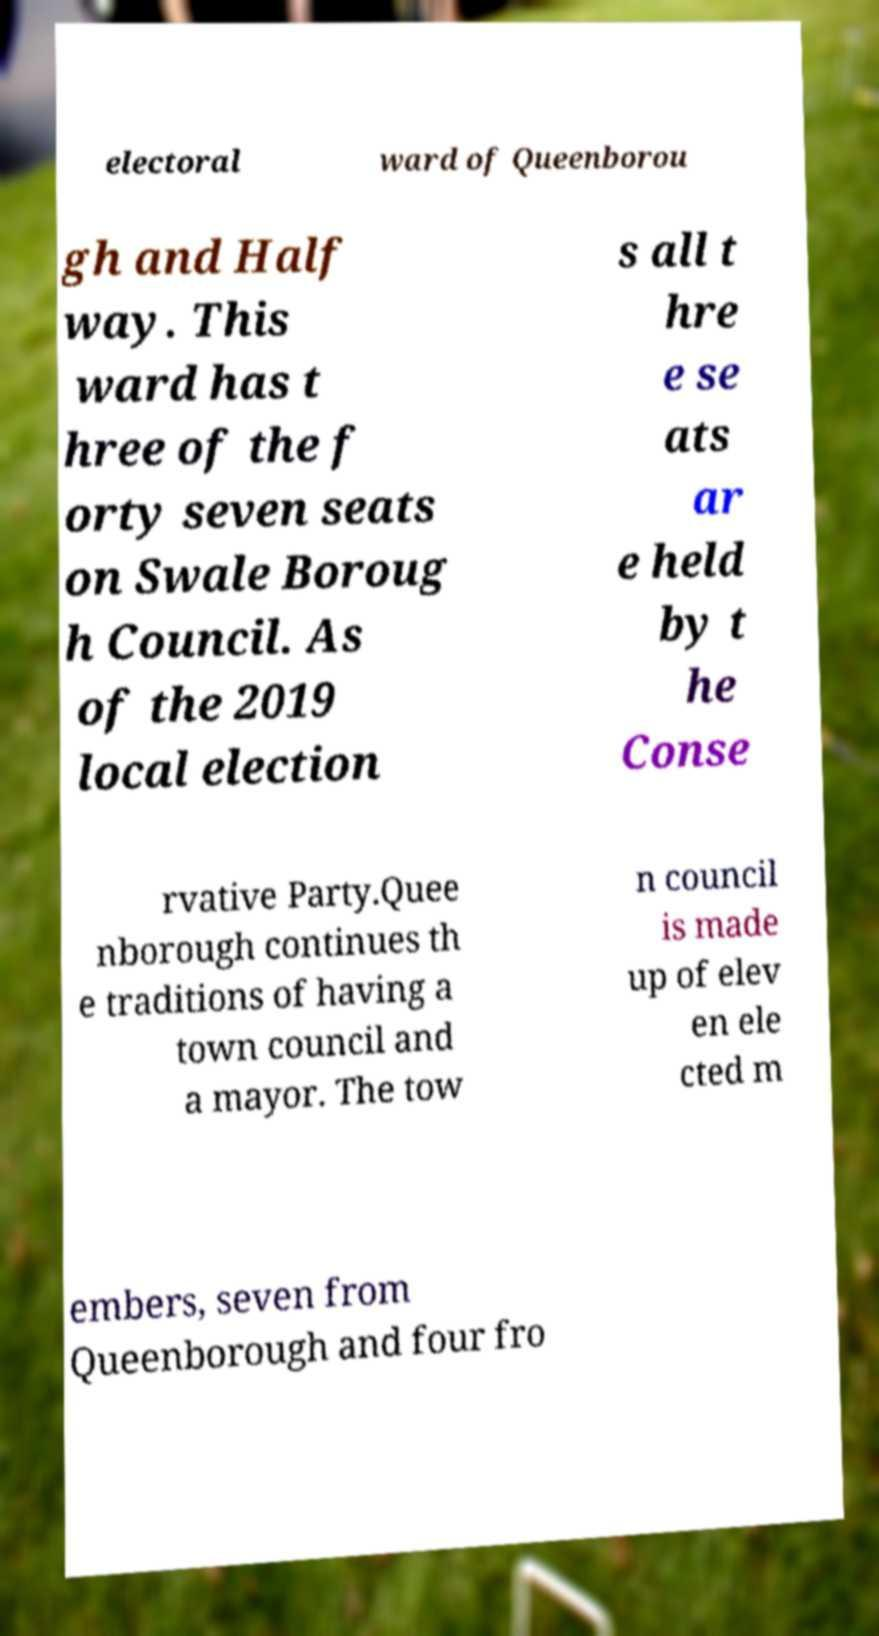What messages or text are displayed in this image? I need them in a readable, typed format. electoral ward of Queenborou gh and Half way. This ward has t hree of the f orty seven seats on Swale Boroug h Council. As of the 2019 local election s all t hre e se ats ar e held by t he Conse rvative Party.Quee nborough continues th e traditions of having a town council and a mayor. The tow n council is made up of elev en ele cted m embers, seven from Queenborough and four fro 